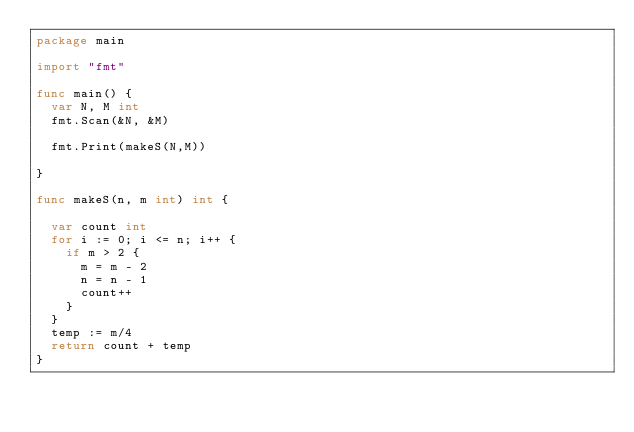<code> <loc_0><loc_0><loc_500><loc_500><_Go_>package main

import "fmt"

func main() {
	var N, M int
	fmt.Scan(&N, &M)

	fmt.Print(makeS(N,M))

}

func makeS(n, m int) int {

	var count int
	for i := 0; i <= n; i++ {
		if m > 2 {
			m = m - 2
			n = n - 1
			count++
		}
	}
	temp := m/4
	return count + temp
}</code> 